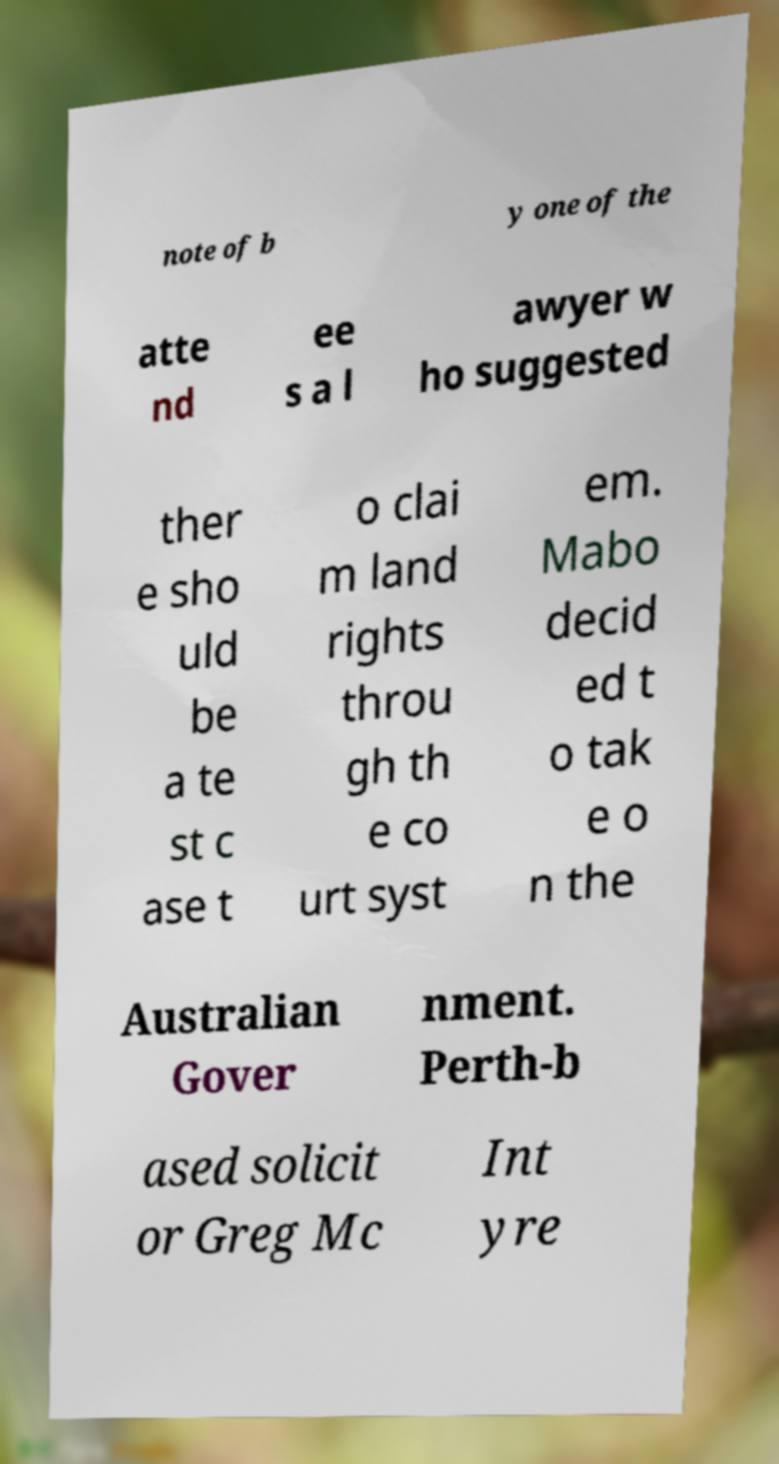There's text embedded in this image that I need extracted. Can you transcribe it verbatim? note of b y one of the atte nd ee s a l awyer w ho suggested ther e sho uld be a te st c ase t o clai m land rights throu gh th e co urt syst em. Mabo decid ed t o tak e o n the Australian Gover nment. Perth-b ased solicit or Greg Mc Int yre 